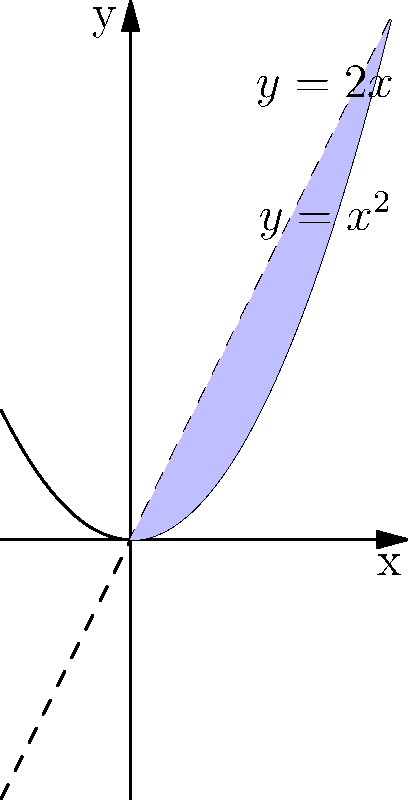Consider the curves $y=x^2$ and $y=2x$. Calculate the area of the region bounded by these two curves. How might this problem relate to Paul Tough's emphasis on developing persistence and problem-solving skills in education? To solve this problem, we'll follow these steps:

1) First, we need to find the points of intersection of the two curves:
   $x^2 = 2x$
   $x^2 - 2x = 0$
   $x(x - 2) = 0$
   $x = 0$ or $x = 2$

2) The area between the curves is given by the integral:
   $$A = \int_{0}^{2} (2x - x^2) dx$$

3) Let's evaluate this integral:
   $$A = \int_{0}^{2} (2x - x^2) dx = [x^2 - \frac{x^3}{3}]_{0}^{2}$$

4) Evaluating at the limits:
   $$A = (4 - \frac{8}{3}) - (0 - 0) = \frac{4}{3}$$

5) Therefore, the area is $\frac{4}{3}$ square units.

This problem relates to Paul Tough's educational philosophy by:
- Requiring persistence to work through multiple steps
- Encouraging problem-solving by breaking down a complex problem into manageable parts
- Promoting metacognition as students reflect on their approach
- Developing mathematical grit through a challenging, multi-step problem

These align with Tough's emphasis on non-cognitive skills and the importance of productive struggle in learning.
Answer: $\frac{4}{3}$ square units 